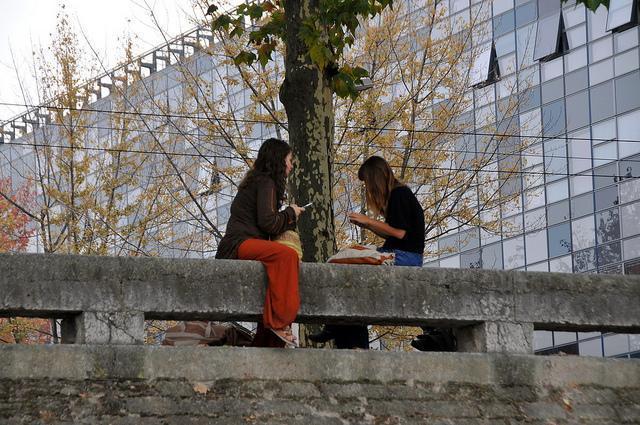How many rows of telephone wires can be seen?
Give a very brief answer. 3. How many people are in the photo?
Give a very brief answer. 2. 